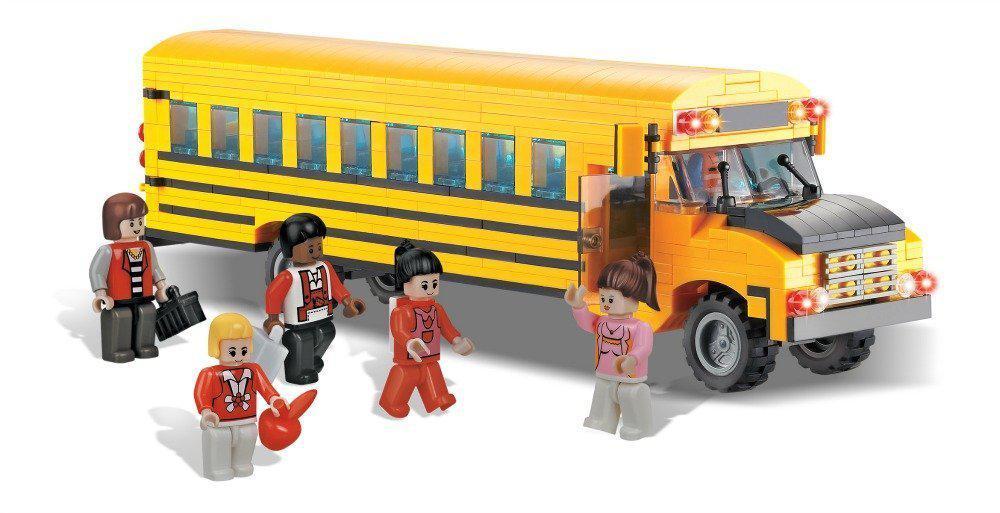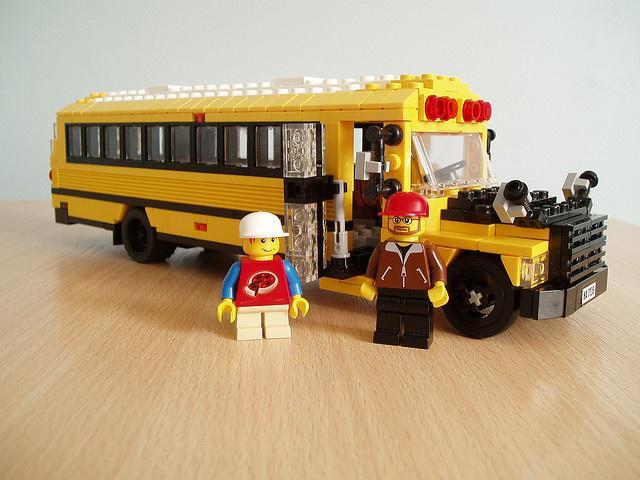The first image is the image on the left, the second image is the image on the right. Examine the images to the left and right. Is the description "There is a yellow school bus constructed out of Lego in the center of both images." accurate? Answer yes or no. Yes. 